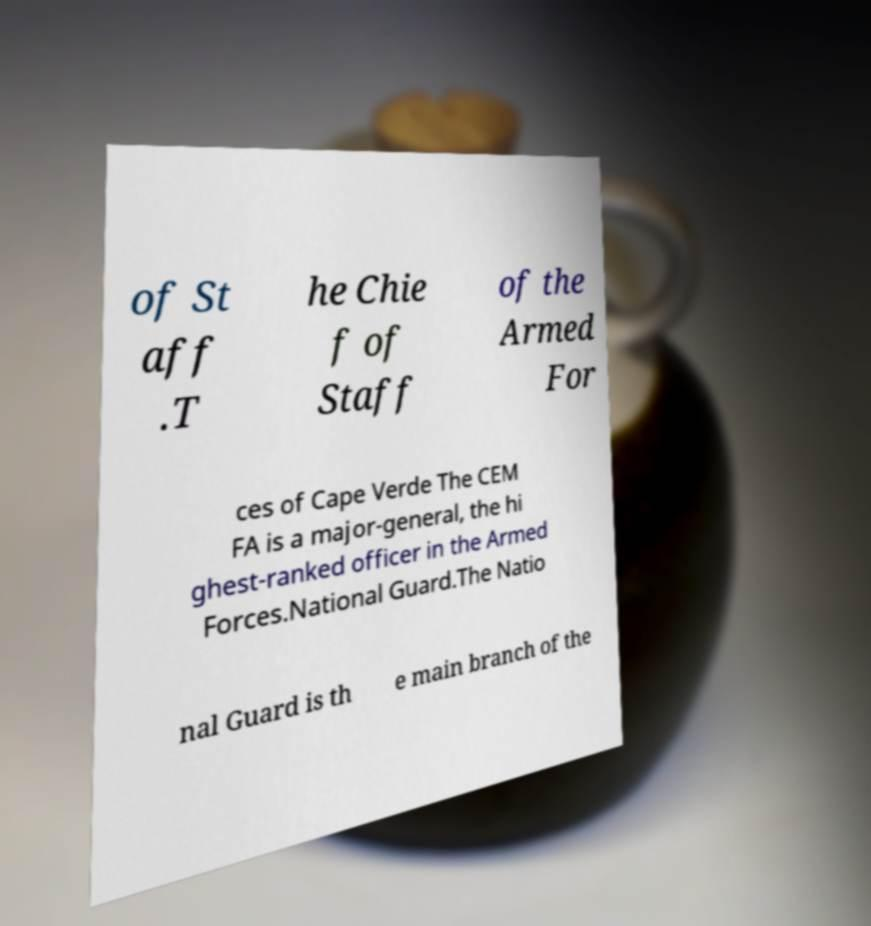Can you accurately transcribe the text from the provided image for me? of St aff .T he Chie f of Staff of the Armed For ces of Cape Verde The CEM FA is a major-general, the hi ghest-ranked officer in the Armed Forces.National Guard.The Natio nal Guard is th e main branch of the 